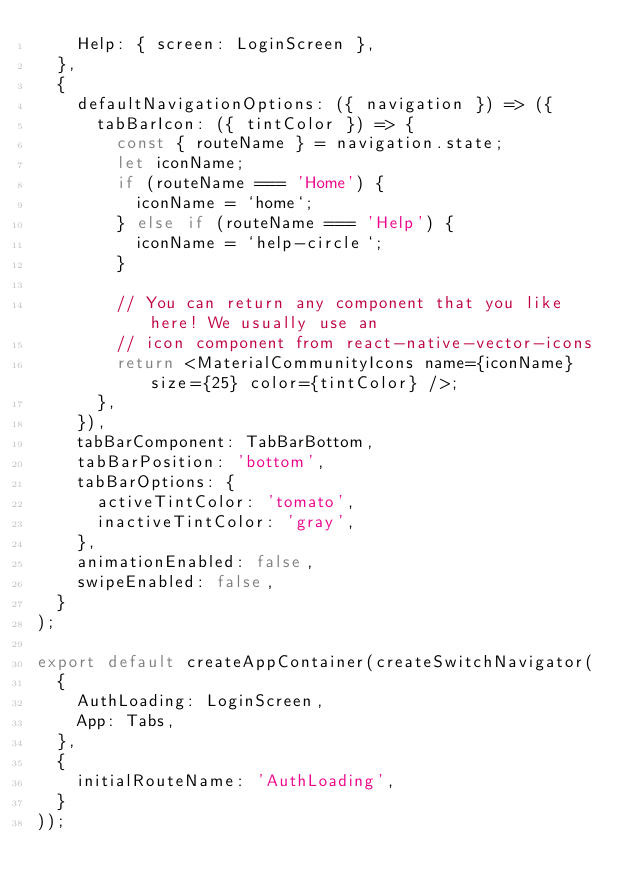<code> <loc_0><loc_0><loc_500><loc_500><_TypeScript_>    Help: { screen: LoginScreen },
  },
  {
    defaultNavigationOptions: ({ navigation }) => ({
      tabBarIcon: ({ tintColor }) => {
        const { routeName } = navigation.state;
        let iconName;
        if (routeName === 'Home') {
          iconName = `home`;
        } else if (routeName === 'Help') {
          iconName = `help-circle`;
        }

        // You can return any component that you like here! We usually use an
        // icon component from react-native-vector-icons
        return <MaterialCommunityIcons name={iconName} size={25} color={tintColor} />;
      },
    }),
    tabBarComponent: TabBarBottom,
    tabBarPosition: 'bottom',
    tabBarOptions: {
      activeTintColor: 'tomato',
      inactiveTintColor: 'gray',
    },
    animationEnabled: false,
    swipeEnabled: false,
  }
);

export default createAppContainer(createSwitchNavigator(
  {
    AuthLoading: LoginScreen,
    App: Tabs,
  },
  {
    initialRouteName: 'AuthLoading',
  }
));

</code> 